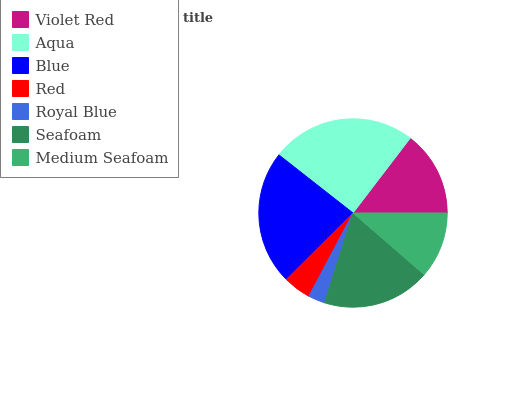Is Royal Blue the minimum?
Answer yes or no. Yes. Is Aqua the maximum?
Answer yes or no. Yes. Is Blue the minimum?
Answer yes or no. No. Is Blue the maximum?
Answer yes or no. No. Is Aqua greater than Blue?
Answer yes or no. Yes. Is Blue less than Aqua?
Answer yes or no. Yes. Is Blue greater than Aqua?
Answer yes or no. No. Is Aqua less than Blue?
Answer yes or no. No. Is Violet Red the high median?
Answer yes or no. Yes. Is Violet Red the low median?
Answer yes or no. Yes. Is Seafoam the high median?
Answer yes or no. No. Is Royal Blue the low median?
Answer yes or no. No. 